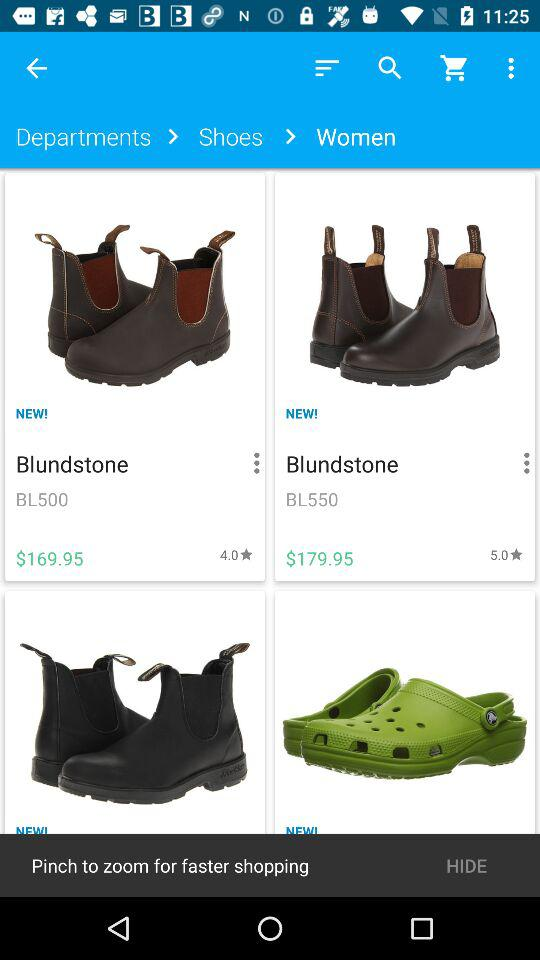How many items have a rating of 5.0?
Answer the question using a single word or phrase. 1 